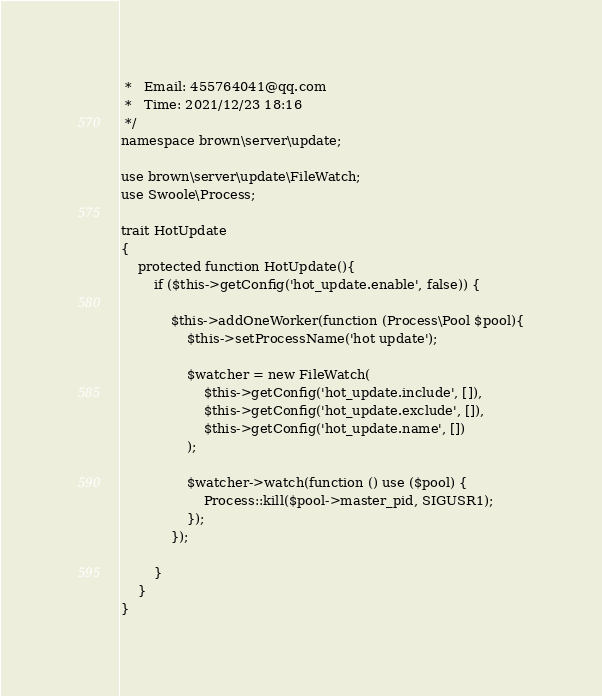Convert code to text. <code><loc_0><loc_0><loc_500><loc_500><_PHP_> *   Email: 455764041@qq.com
 *   Time: 2021/12/23 18:16
 */
namespace brown\server\update;

use brown\server\update\FileWatch;
use Swoole\Process;

trait HotUpdate
{
    protected function HotUpdate(){
        if ($this->getConfig('hot_update.enable', false)) {

            $this->addOneWorker(function (Process\Pool $pool){
                $this->setProcessName('hot update');

                $watcher = new FileWatch(
                    $this->getConfig('hot_update.include', []),
                    $this->getConfig('hot_update.exclude', []),
                    $this->getConfig('hot_update.name', [])
                );

                $watcher->watch(function () use ($pool) {
                    Process::kill($pool->master_pid, SIGUSR1);
                });
            });

        }
    }
}</code> 